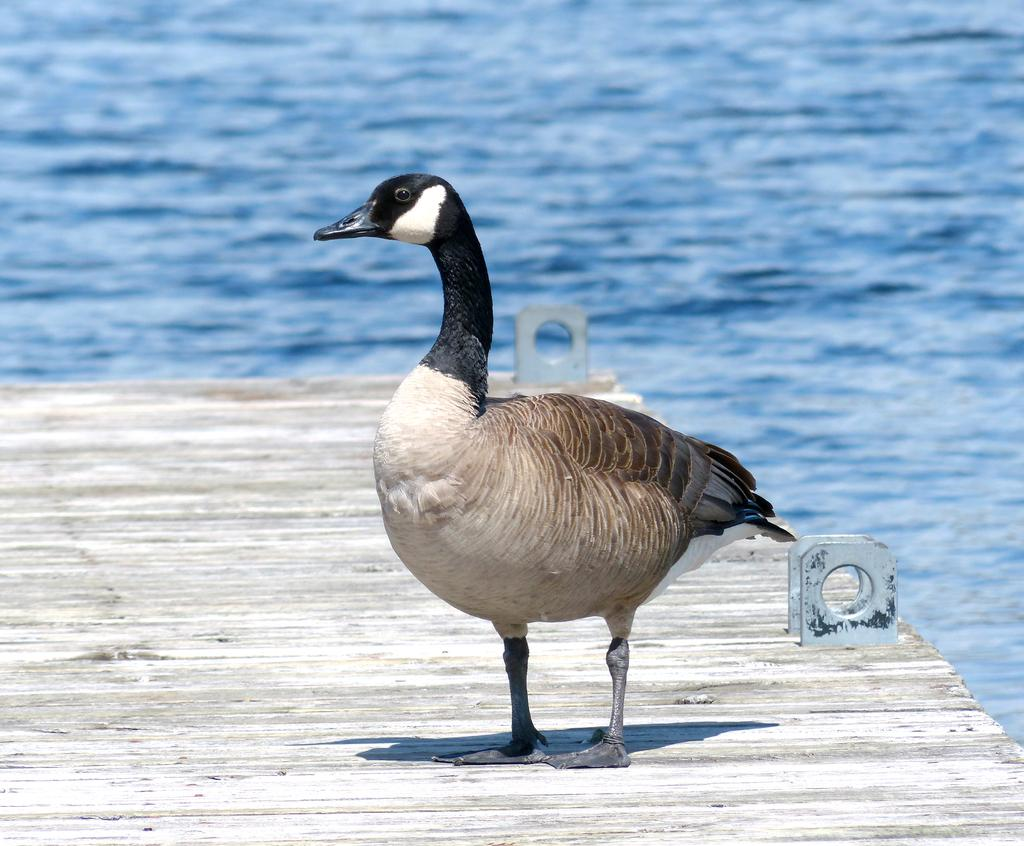What animal is present in the image? There is a duck in the image. Where is the duck located? The duck is standing on a wooden bridge. What can be seen in the background of the image? There is a sea in the background of the image. What type of music is the duck playing on the wooden bridge? There is no music or instrument present in the image, so the duck is not playing any music. 